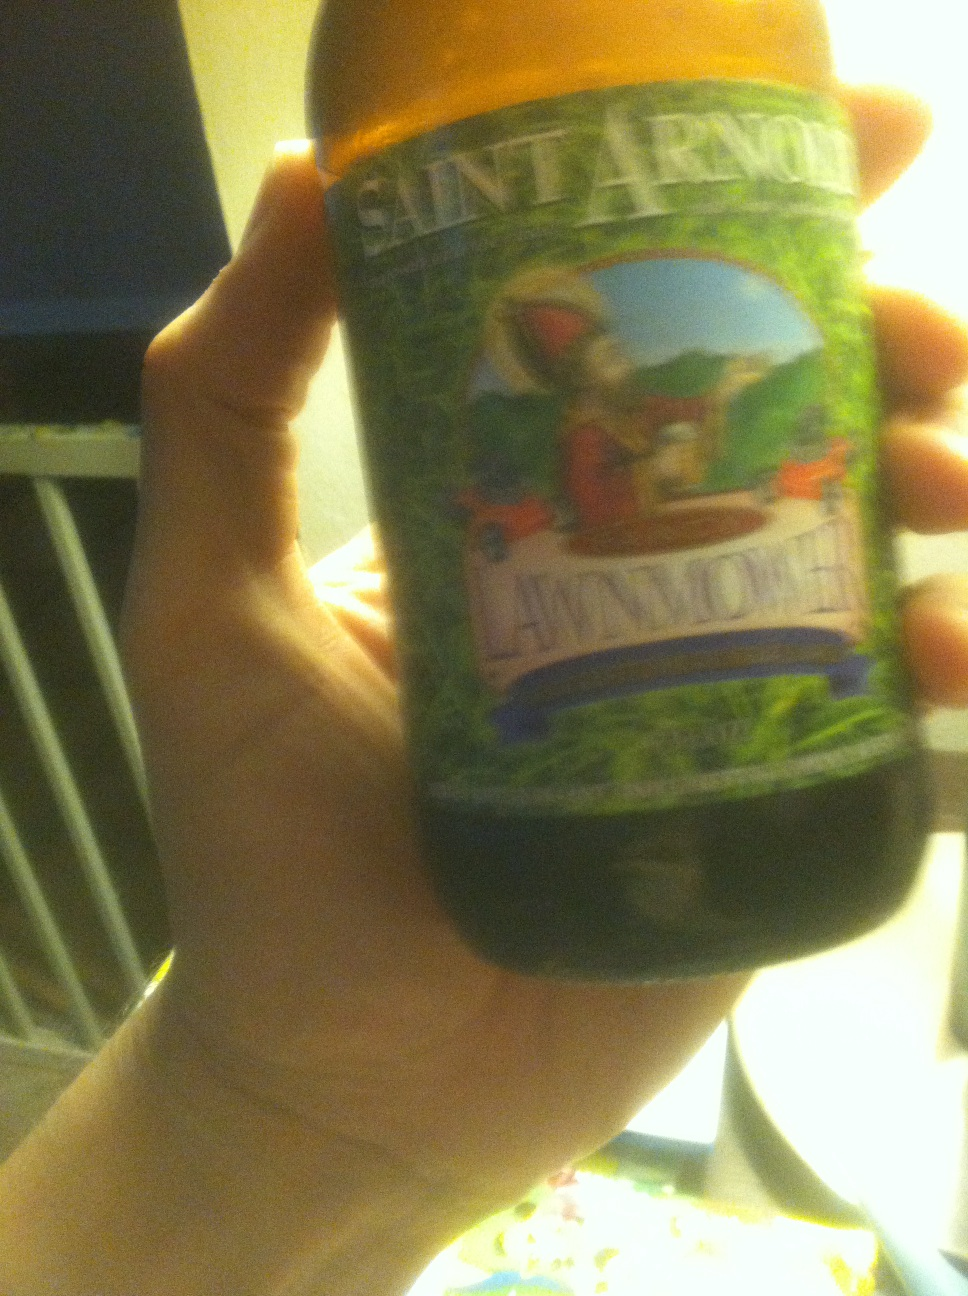What foods pair well with this type of beer? Kölsch-style beers like Saint Arnold's Lawnmower pair excellently with light dishes such as grilled chicken, salads, or fish, complementing their delicate flavors without overpowering them. Are there any specific dishes that are a favorite with this beer? Yes, a popular pairing is a classic summer barbecue spread including grilled sausages or shrimp skewers; the beer's light, crisp taste balances the smoky flavors beautifully. 